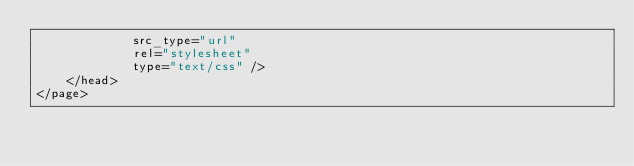Convert code to text. <code><loc_0><loc_0><loc_500><loc_500><_XML_>             src_type="url"
             rel="stylesheet"
             type="text/css" />
    </head>
</page>
</code> 